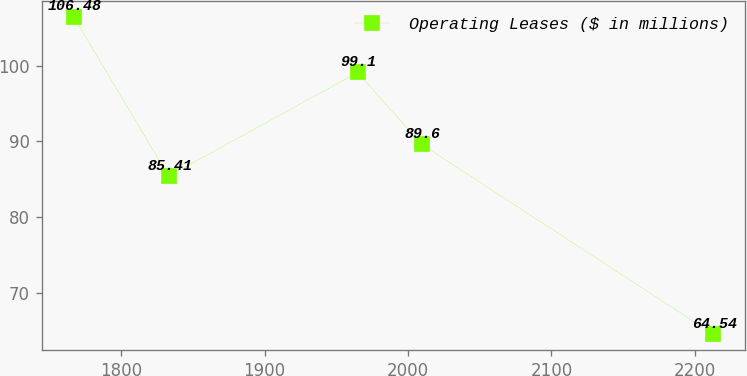<chart> <loc_0><loc_0><loc_500><loc_500><line_chart><ecel><fcel>Operating Leases ($ in millions)<nl><fcel>1766.73<fcel>106.48<nl><fcel>1832.98<fcel>85.41<nl><fcel>1964.87<fcel>99.1<nl><fcel>2009.48<fcel>89.6<nl><fcel>2212.85<fcel>64.54<nl></chart> 